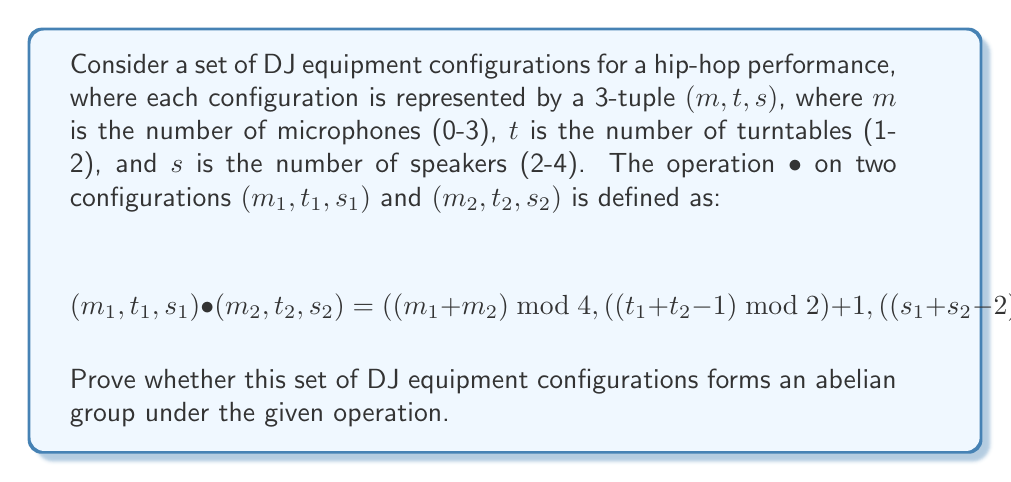Help me with this question. To prove whether this set of DJ equipment configurations forms an abelian group, we need to check if it satisfies the four group axioms and the commutativity property:

1. Closure: For any two elements in the set, their operation should result in an element within the set.
2. Associativity: $(a • b) • c = a • (b • c)$ for all elements $a, b, c$ in the set.
3. Identity element: There exists an element $e$ such that $a • e = e • a = a$ for all elements $a$ in the set.
4. Inverse element: For each element $a$, there exists an element $b$ such that $a • b = b • a = e$, where $e$ is the identity element.
5. Commutativity: $a • b = b • a$ for all elements $a, b$ in the set.

Let's check each property:

1. Closure: The operation ensures that $m$ is always between 0 and 3, $t$ is always 1 or 2, and $s$ is always between 2 and 4. Therefore, the result is always in the set.

2. Associativity: This property holds due to the modular arithmetic used in the operation.

3. Identity element: The identity element is $(0, 1, 2)$, as it leaves any configuration unchanged when operated with.

4. Inverse element: For any configuration $(m, t, s)$, its inverse is:
   $((4-m) \bmod 4, t, (6-s) \bmod 3 + 2)$

5. Commutativity: Let's check if $(m_1, t_1, s_1) • (m_2, t_2, s_2) = (m_2, t_2, s_2) • (m_1, t_1, s_1)$

   For $m$: $(m_1 + m_2) \bmod 4 = (m_2 + m_1) \bmod 4$
   For $t$: $((t_1 + t_2 - 1) \bmod 2) + 1 = ((t_2 + t_1 - 1) \bmod 2) + 1$
   For $s$: $((s_1 + s_2 - 2) \bmod 3) + 2 = ((s_2 + s_1 - 2) \bmod 3) + 2$

   All components are commutative, so the operation is commutative.

Since all five properties (four group axioms and commutativity) are satisfied, this set of DJ equipment configurations forms an abelian group under the given operation.
Answer: Yes, the given set of DJ equipment configurations forms an abelian group under the specified operation. 